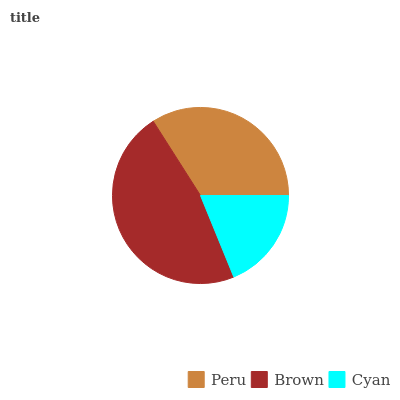Is Cyan the minimum?
Answer yes or no. Yes. Is Brown the maximum?
Answer yes or no. Yes. Is Brown the minimum?
Answer yes or no. No. Is Cyan the maximum?
Answer yes or no. No. Is Brown greater than Cyan?
Answer yes or no. Yes. Is Cyan less than Brown?
Answer yes or no. Yes. Is Cyan greater than Brown?
Answer yes or no. No. Is Brown less than Cyan?
Answer yes or no. No. Is Peru the high median?
Answer yes or no. Yes. Is Peru the low median?
Answer yes or no. Yes. Is Cyan the high median?
Answer yes or no. No. Is Brown the low median?
Answer yes or no. No. 